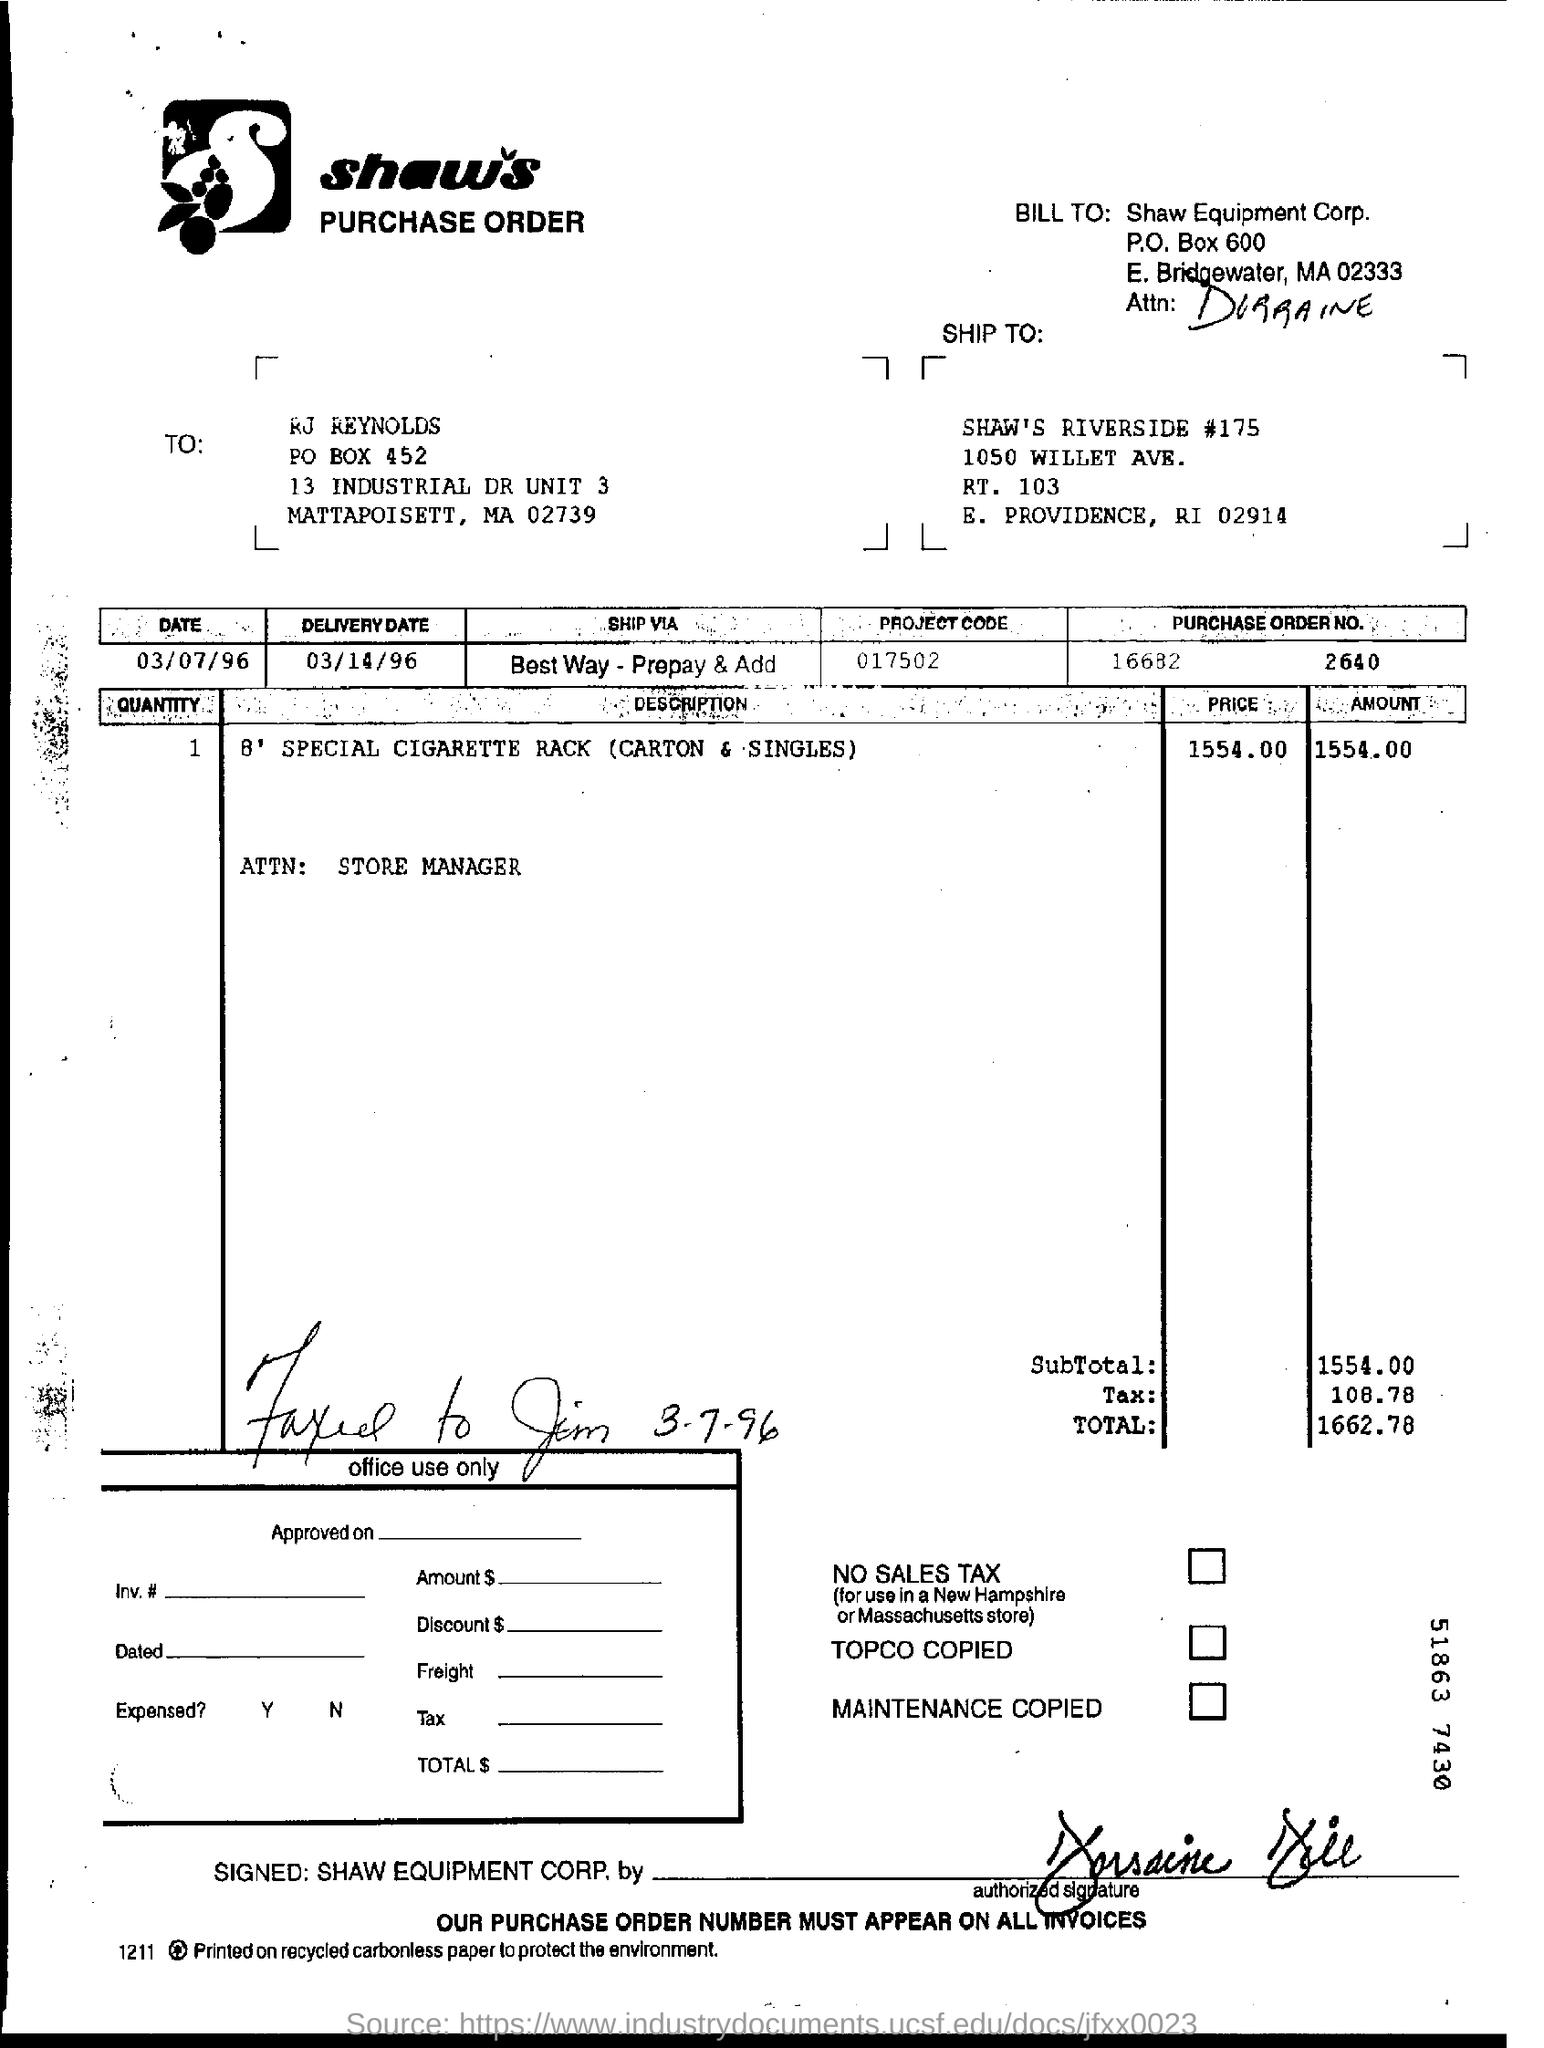What is the delivery date mentioned in the purchase order?
Offer a terse response. 03/14/96. What is the project code given in the purchase order?
Offer a terse response. 017502. What is the total amount mentioned in the purchase order?
Make the answer very short. 1662.78. 